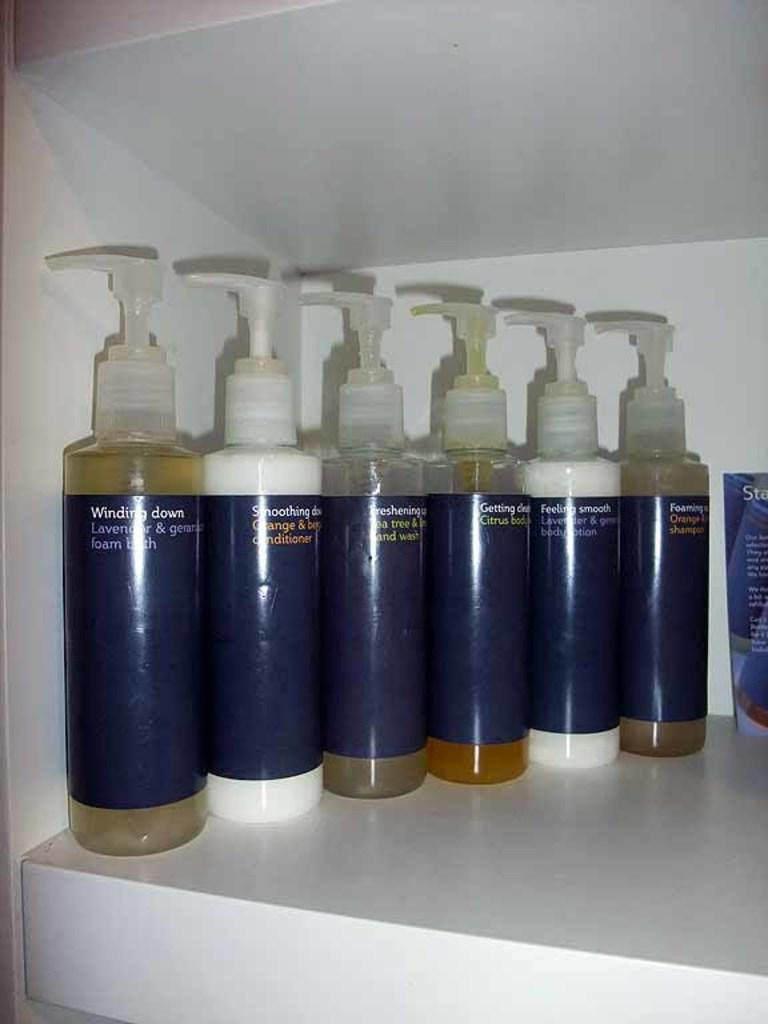What objects are in the image? There is a group of plastic bottles in the image. Where are the plastic bottles located? The plastic bottles are placed on a shelf. What type of party is being held in the image? There is no party depicted in the image; it only shows a group of plastic bottles on a shelf. 